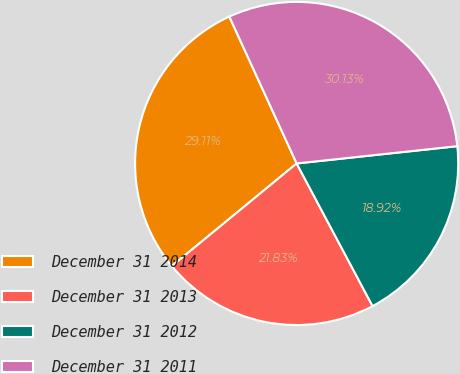Convert chart. <chart><loc_0><loc_0><loc_500><loc_500><pie_chart><fcel>December 31 2014<fcel>December 31 2013<fcel>December 31 2012<fcel>December 31 2011<nl><fcel>29.11%<fcel>21.83%<fcel>18.92%<fcel>30.13%<nl></chart> 